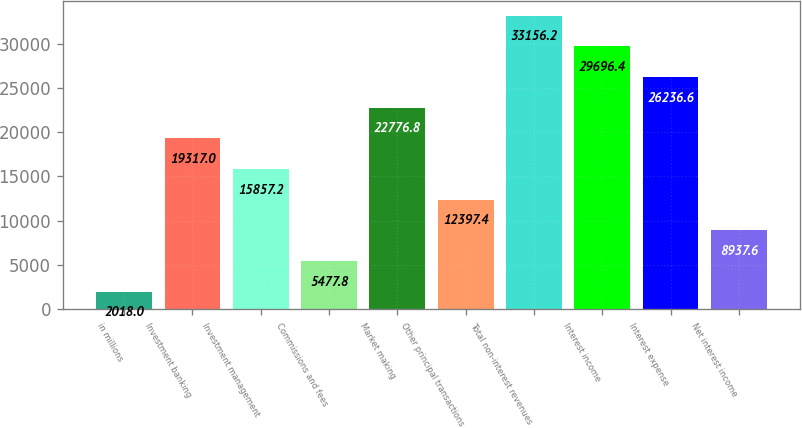<chart> <loc_0><loc_0><loc_500><loc_500><bar_chart><fcel>in millions<fcel>Investment banking<fcel>Investment management<fcel>Commissions and fees<fcel>Market making<fcel>Other principal transactions<fcel>Total non-interest revenues<fcel>Interest income<fcel>Interest expense<fcel>Net interest income<nl><fcel>2018<fcel>19317<fcel>15857.2<fcel>5477.8<fcel>22776.8<fcel>12397.4<fcel>33156.2<fcel>29696.4<fcel>26236.6<fcel>8937.6<nl></chart> 